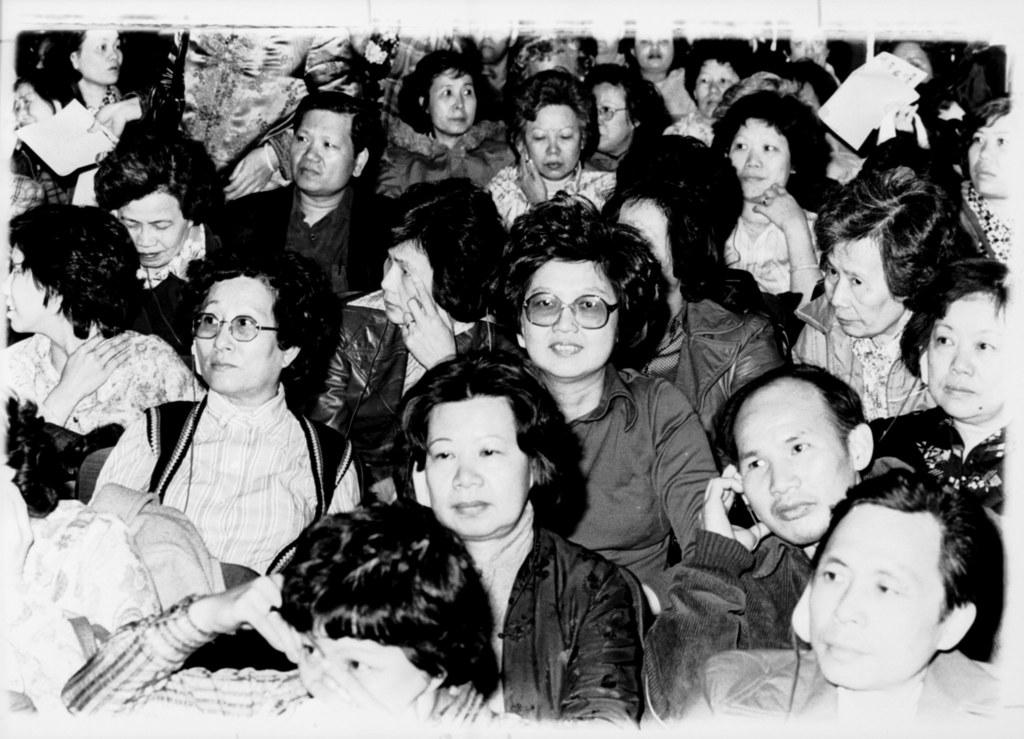What is the color scheme of the image? The image is black and white. What can be seen in the image? There is a group of people in the image. What are the people in the image doing? The people are sitting. Can you hear the bell ringing in the image? There is no bell present in the image, so it cannot be heard. 